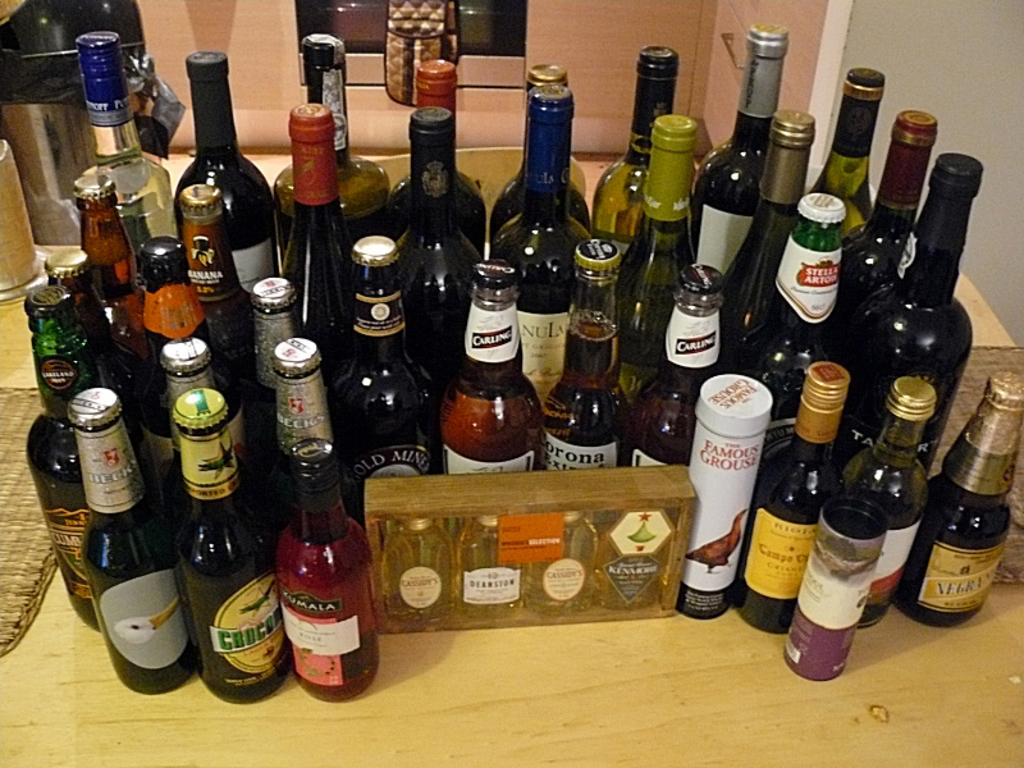<image>
Provide a brief description of the given image. An array of bottles and one canister - the canister is a product called Famous Grouse. 